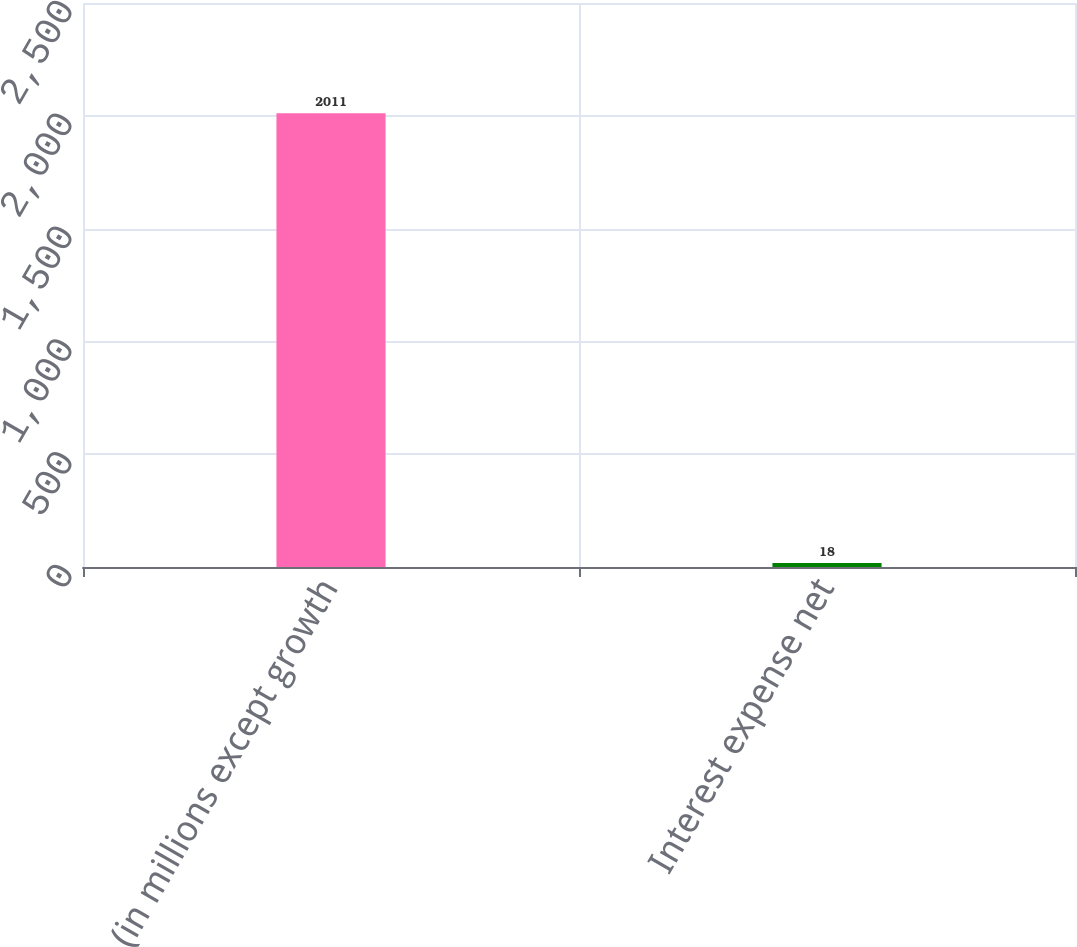Convert chart. <chart><loc_0><loc_0><loc_500><loc_500><bar_chart><fcel>(in millions except growth<fcel>Interest expense net<nl><fcel>2011<fcel>18<nl></chart> 